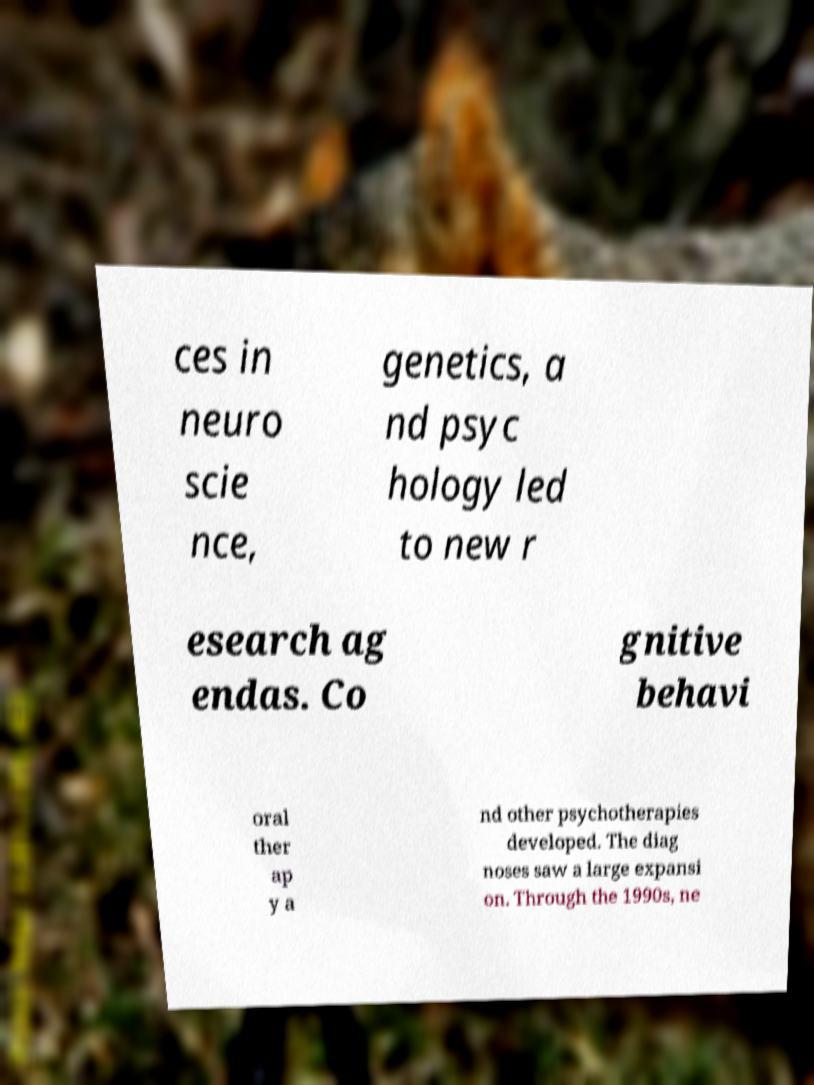There's text embedded in this image that I need extracted. Can you transcribe it verbatim? ces in neuro scie nce, genetics, a nd psyc hology led to new r esearch ag endas. Co gnitive behavi oral ther ap y a nd other psychotherapies developed. The diag noses saw a large expansi on. Through the 1990s, ne 